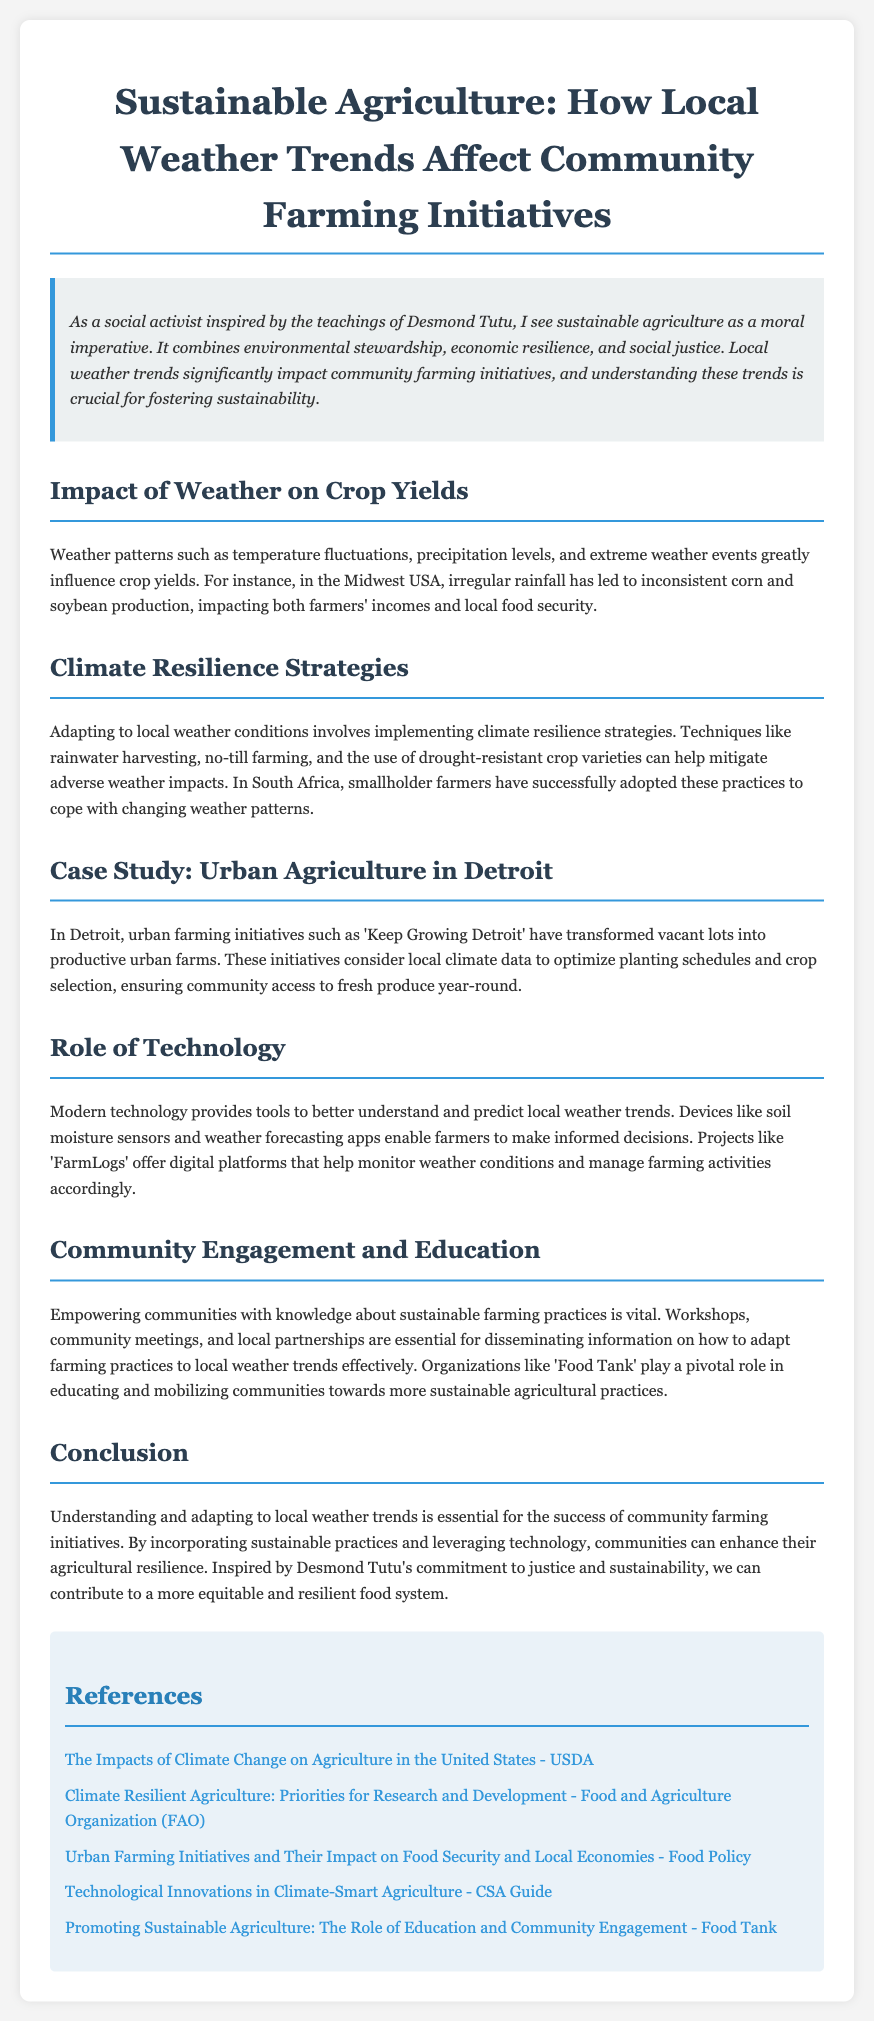What is the main focus of the document? The document primarily focuses on how local weather trends affect community farming initiatives and sustainable agriculture.
Answer: Sustainable agriculture and weather trends What are some climate resilience strategies mentioned? The document lists rainwater harvesting, no-till farming, and drought-resistant crop varieties as resilience strategies.
Answer: Rainwater harvesting, no-till farming, drought-resistant crop varieties Which city is highlighted in the case study? The case study focuses on urban agriculture initiatives in Detroit.
Answer: Detroit What does the 'Keep Growing Detroit' initiative aim to achieve? The initiative transforms vacant lots into productive urban farms, optimizing for local climate data.
Answer: Transform vacant lots into productive urban farms What role does modern technology play in agriculture according to the report? Modern technology provides tools to understand and predict weather trends, aiding farmers in decision-making.
Answer: Tools for understanding and predicting weather trends What is emphasized as important for community engagement? The document emphasizes the need for workshops, community meetings, and local partnerships for knowledge dissemination.
Answer: Workshops, community meetings, local partnerships Who plays a pivotal role in educating communities about sustainable agricultural practices? 'Food Tank' is highlighted as an organization that educates and mobilizes communities.
Answer: Food Tank What is the primary motivation behind sustainable agriculture as stated in the document? The primary motivation is described as a moral imperative combining environmental stewardship and social justice.
Answer: Moral imperative combining environmental stewardship and social justice What impact do irregular rainfall patterns have on farmers? Irregular rainfall leads to inconsistent corn and soybean production, affecting incomes and food security.
Answer: Inconsistent production affects incomes and food security 